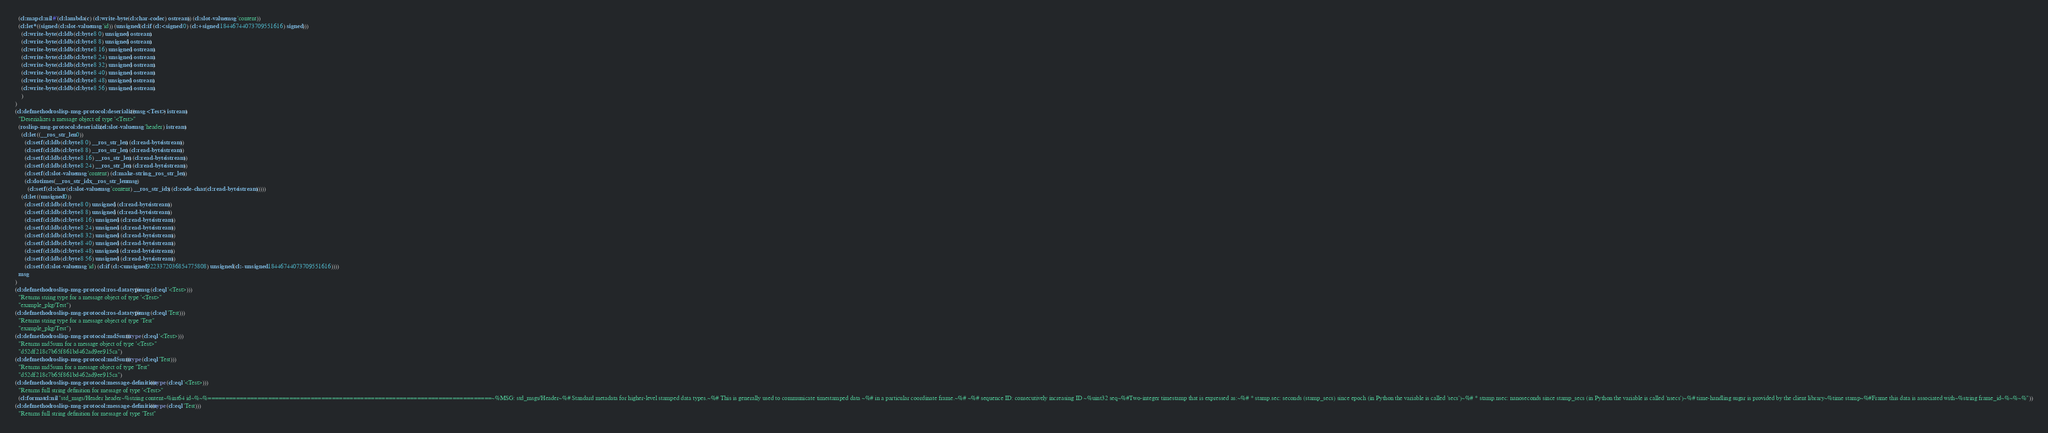<code> <loc_0><loc_0><loc_500><loc_500><_Lisp_>  (cl:map cl:nil #'(cl:lambda (c) (cl:write-byte (cl:char-code c) ostream)) (cl:slot-value msg 'content))
  (cl:let* ((signed (cl:slot-value msg 'id)) (unsigned (cl:if (cl:< signed 0) (cl:+ signed 18446744073709551616) signed)))
    (cl:write-byte (cl:ldb (cl:byte 8 0) unsigned) ostream)
    (cl:write-byte (cl:ldb (cl:byte 8 8) unsigned) ostream)
    (cl:write-byte (cl:ldb (cl:byte 8 16) unsigned) ostream)
    (cl:write-byte (cl:ldb (cl:byte 8 24) unsigned) ostream)
    (cl:write-byte (cl:ldb (cl:byte 8 32) unsigned) ostream)
    (cl:write-byte (cl:ldb (cl:byte 8 40) unsigned) ostream)
    (cl:write-byte (cl:ldb (cl:byte 8 48) unsigned) ostream)
    (cl:write-byte (cl:ldb (cl:byte 8 56) unsigned) ostream)
    )
)
(cl:defmethod roslisp-msg-protocol:deserialize ((msg <Test>) istream)
  "Deserializes a message object of type '<Test>"
  (roslisp-msg-protocol:deserialize (cl:slot-value msg 'header) istream)
    (cl:let ((__ros_str_len 0))
      (cl:setf (cl:ldb (cl:byte 8 0) __ros_str_len) (cl:read-byte istream))
      (cl:setf (cl:ldb (cl:byte 8 8) __ros_str_len) (cl:read-byte istream))
      (cl:setf (cl:ldb (cl:byte 8 16) __ros_str_len) (cl:read-byte istream))
      (cl:setf (cl:ldb (cl:byte 8 24) __ros_str_len) (cl:read-byte istream))
      (cl:setf (cl:slot-value msg 'content) (cl:make-string __ros_str_len))
      (cl:dotimes (__ros_str_idx __ros_str_len msg)
        (cl:setf (cl:char (cl:slot-value msg 'content) __ros_str_idx) (cl:code-char (cl:read-byte istream)))))
    (cl:let ((unsigned 0))
      (cl:setf (cl:ldb (cl:byte 8 0) unsigned) (cl:read-byte istream))
      (cl:setf (cl:ldb (cl:byte 8 8) unsigned) (cl:read-byte istream))
      (cl:setf (cl:ldb (cl:byte 8 16) unsigned) (cl:read-byte istream))
      (cl:setf (cl:ldb (cl:byte 8 24) unsigned) (cl:read-byte istream))
      (cl:setf (cl:ldb (cl:byte 8 32) unsigned) (cl:read-byte istream))
      (cl:setf (cl:ldb (cl:byte 8 40) unsigned) (cl:read-byte istream))
      (cl:setf (cl:ldb (cl:byte 8 48) unsigned) (cl:read-byte istream))
      (cl:setf (cl:ldb (cl:byte 8 56) unsigned) (cl:read-byte istream))
      (cl:setf (cl:slot-value msg 'id) (cl:if (cl:< unsigned 9223372036854775808) unsigned (cl:- unsigned 18446744073709551616))))
  msg
)
(cl:defmethod roslisp-msg-protocol:ros-datatype ((msg (cl:eql '<Test>)))
  "Returns string type for a message object of type '<Test>"
  "example_pkg/Test")
(cl:defmethod roslisp-msg-protocol:ros-datatype ((msg (cl:eql 'Test)))
  "Returns string type for a message object of type 'Test"
  "example_pkg/Test")
(cl:defmethod roslisp-msg-protocol:md5sum ((type (cl:eql '<Test>)))
  "Returns md5sum for a message object of type '<Test>"
  "d52df218c7b65f861bd462ad9ee915ca")
(cl:defmethod roslisp-msg-protocol:md5sum ((type (cl:eql 'Test)))
  "Returns md5sum for a message object of type 'Test"
  "d52df218c7b65f861bd462ad9ee915ca")
(cl:defmethod roslisp-msg-protocol:message-definition ((type (cl:eql '<Test>)))
  "Returns full string definition for message of type '<Test>"
  (cl:format cl:nil "std_msgs/Header header~%string content~%int64 id~%~%================================================================================~%MSG: std_msgs/Header~%# Standard metadata for higher-level stamped data types.~%# This is generally used to communicate timestamped data ~%# in a particular coordinate frame.~%# ~%# sequence ID: consecutively increasing ID ~%uint32 seq~%#Two-integer timestamp that is expressed as:~%# * stamp.sec: seconds (stamp_secs) since epoch (in Python the variable is called 'secs')~%# * stamp.nsec: nanoseconds since stamp_secs (in Python the variable is called 'nsecs')~%# time-handling sugar is provided by the client library~%time stamp~%#Frame this data is associated with~%string frame_id~%~%~%"))
(cl:defmethod roslisp-msg-protocol:message-definition ((type (cl:eql 'Test)))
  "Returns full string definition for message of type 'Test"</code> 